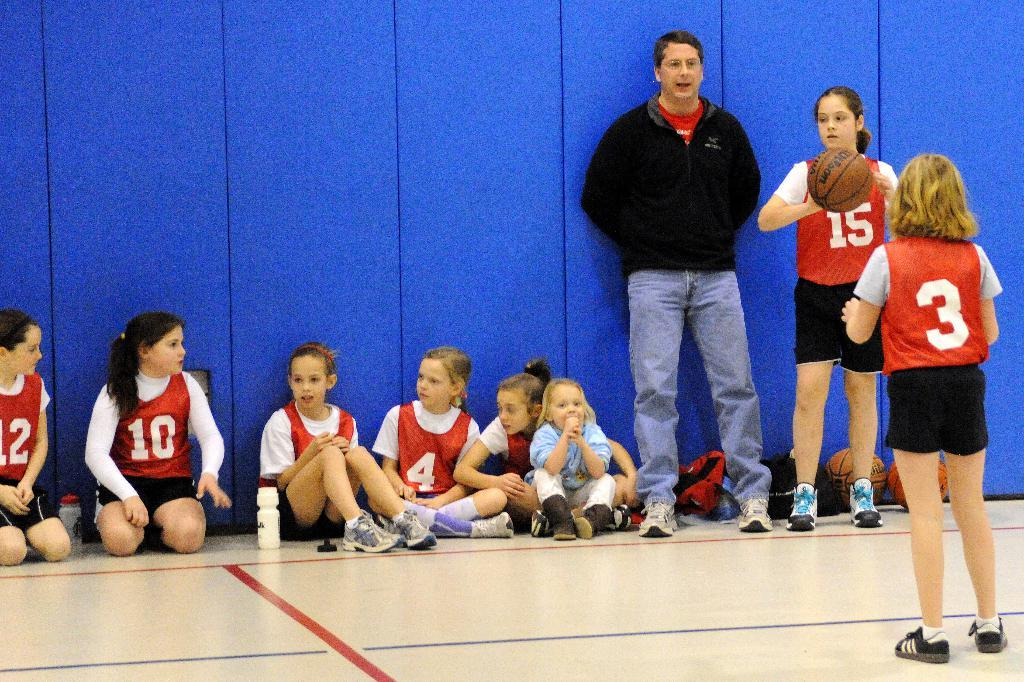What are the people in the image doing? The persons in the image are sitting and standing on the floor. What can be seen in the background of the image? There is a wall in the background of the image. What is the girl on the right side of the image holding? The girl is holding a basketball. What type of teeth can be seen in the image? There are no teeth visible in the image. What mode of transportation is present in the image? There is no mode of transportation present in the image. 